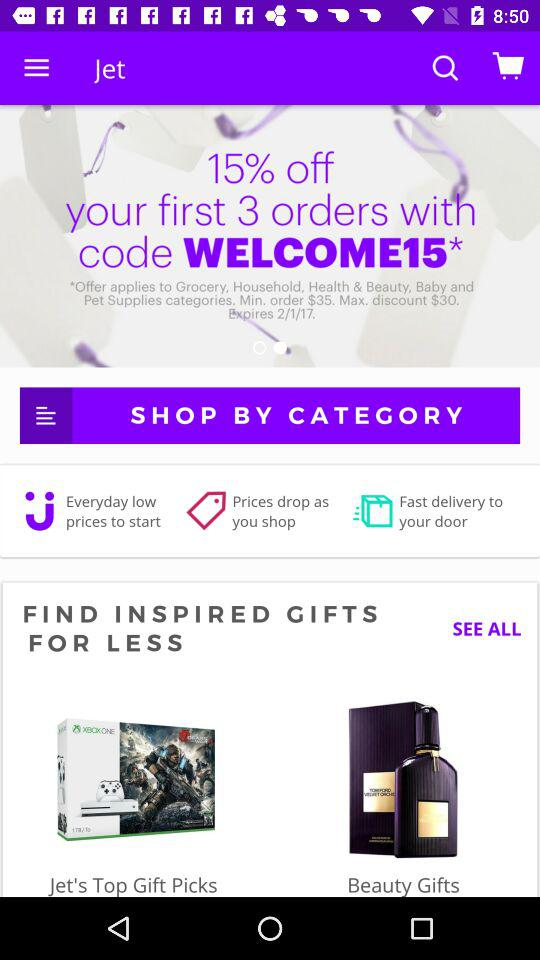What is the expiry date? The expiry date is 2/1/2017. 